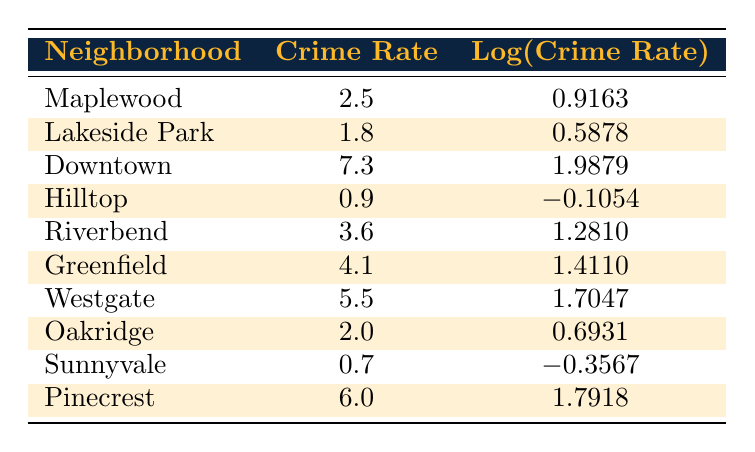What is the crime rate in Downtown? The table shows that the crime rate in Downtown is listed directly under the relevant column. It indicates a crime rate of 7.3 per 1,000 residents.
Answer: 7.3 Which neighborhood has the lowest crime rate? By scanning through the crime rate column, Sunnyvale has the lowest value of 0.7 per 1,000 residents.
Answer: Sunnyvale What is the difference in crime rates between Pinecrest and Hilltop? The crime rate of Pinecrest is 6.0 and for Hilltop, it is 0.9. Therefore, the difference is 6.0 - 0.9 = 5.1.
Answer: 5.1 Is the crime rate in Lakeside Park higher than that in Oakridge? Lakeside Park has a crime rate of 1.8 while Oakridge has 2.0. Comparing these, 1.8 is not higher than 2.0, so the statement is false.
Answer: No What is the average crime rate of the neighborhoods listed? To find the average, sum all the crime rates (2.5 + 1.8 + 7.3 + 0.9 + 3.6 + 4.1 + 5.5 + 2.0 + 0.7 + 6.0 = 34.4) and divide by the number of neighborhoods (10), resulting in an average of 34.4 / 10 = 3.44.
Answer: 3.44 Which neighborhood has a crime rate higher than 5.0? By checking the crime rates, Downtown (7.3), Pinecrest (6.0), and Westgate (5.5) all exceed 5.0.
Answer: Downtown, Pinecrest, Westgate Are there any neighborhoods with a crime rate lower than 1.0? Looking at the table, Hilltop has a crime rate of 0.9, and Sunnyvale has 0.7, both of which are below 1.0. Thus, the answer is yes.
Answer: Yes What is the total crime rate of all neighborhoods combined? The total is calculated by adding all the crime rates (2.5 + 1.8 + 7.3 + 0.9 + 3.6 + 4.1 + 5.5 + 2.0 + 0.7 + 6.0 = 34.4).
Answer: 34.4 Which neighborhood's logarithmic crime rate is closest to zero? By examining the logarithmic values, Hilltop (-0.1054) is closest to zero compared to Sunnyvale (-0.3567).
Answer: Hilltop 